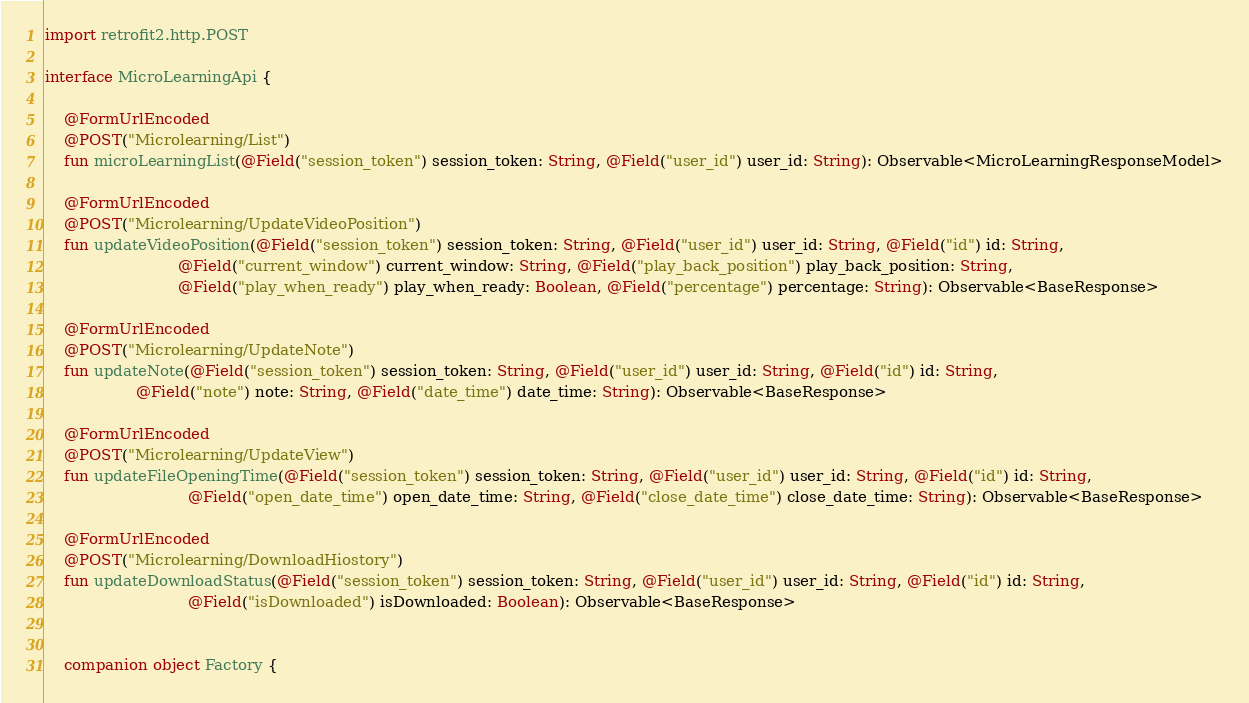Convert code to text. <code><loc_0><loc_0><loc_500><loc_500><_Kotlin_>import retrofit2.http.POST

interface MicroLearningApi {

    @FormUrlEncoded
    @POST("Microlearning/List")
    fun microLearningList(@Field("session_token") session_token: String, @Field("user_id") user_id: String): Observable<MicroLearningResponseModel>

    @FormUrlEncoded
    @POST("Microlearning/UpdateVideoPosition")
    fun updateVideoPosition(@Field("session_token") session_token: String, @Field("user_id") user_id: String, @Field("id") id: String,
                            @Field("current_window") current_window: String, @Field("play_back_position") play_back_position: String,
                            @Field("play_when_ready") play_when_ready: Boolean, @Field("percentage") percentage: String): Observable<BaseResponse>

    @FormUrlEncoded
    @POST("Microlearning/UpdateNote")
    fun updateNote(@Field("session_token") session_token: String, @Field("user_id") user_id: String, @Field("id") id: String,
                   @Field("note") note: String, @Field("date_time") date_time: String): Observable<BaseResponse>

    @FormUrlEncoded
    @POST("Microlearning/UpdateView")
    fun updateFileOpeningTime(@Field("session_token") session_token: String, @Field("user_id") user_id: String, @Field("id") id: String,
                              @Field("open_date_time") open_date_time: String, @Field("close_date_time") close_date_time: String): Observable<BaseResponse>

    @FormUrlEncoded
    @POST("Microlearning/DownloadHiostory")
    fun updateDownloadStatus(@Field("session_token") session_token: String, @Field("user_id") user_id: String, @Field("id") id: String,
                              @Field("isDownloaded") isDownloaded: Boolean): Observable<BaseResponse>


    companion object Factory {</code> 